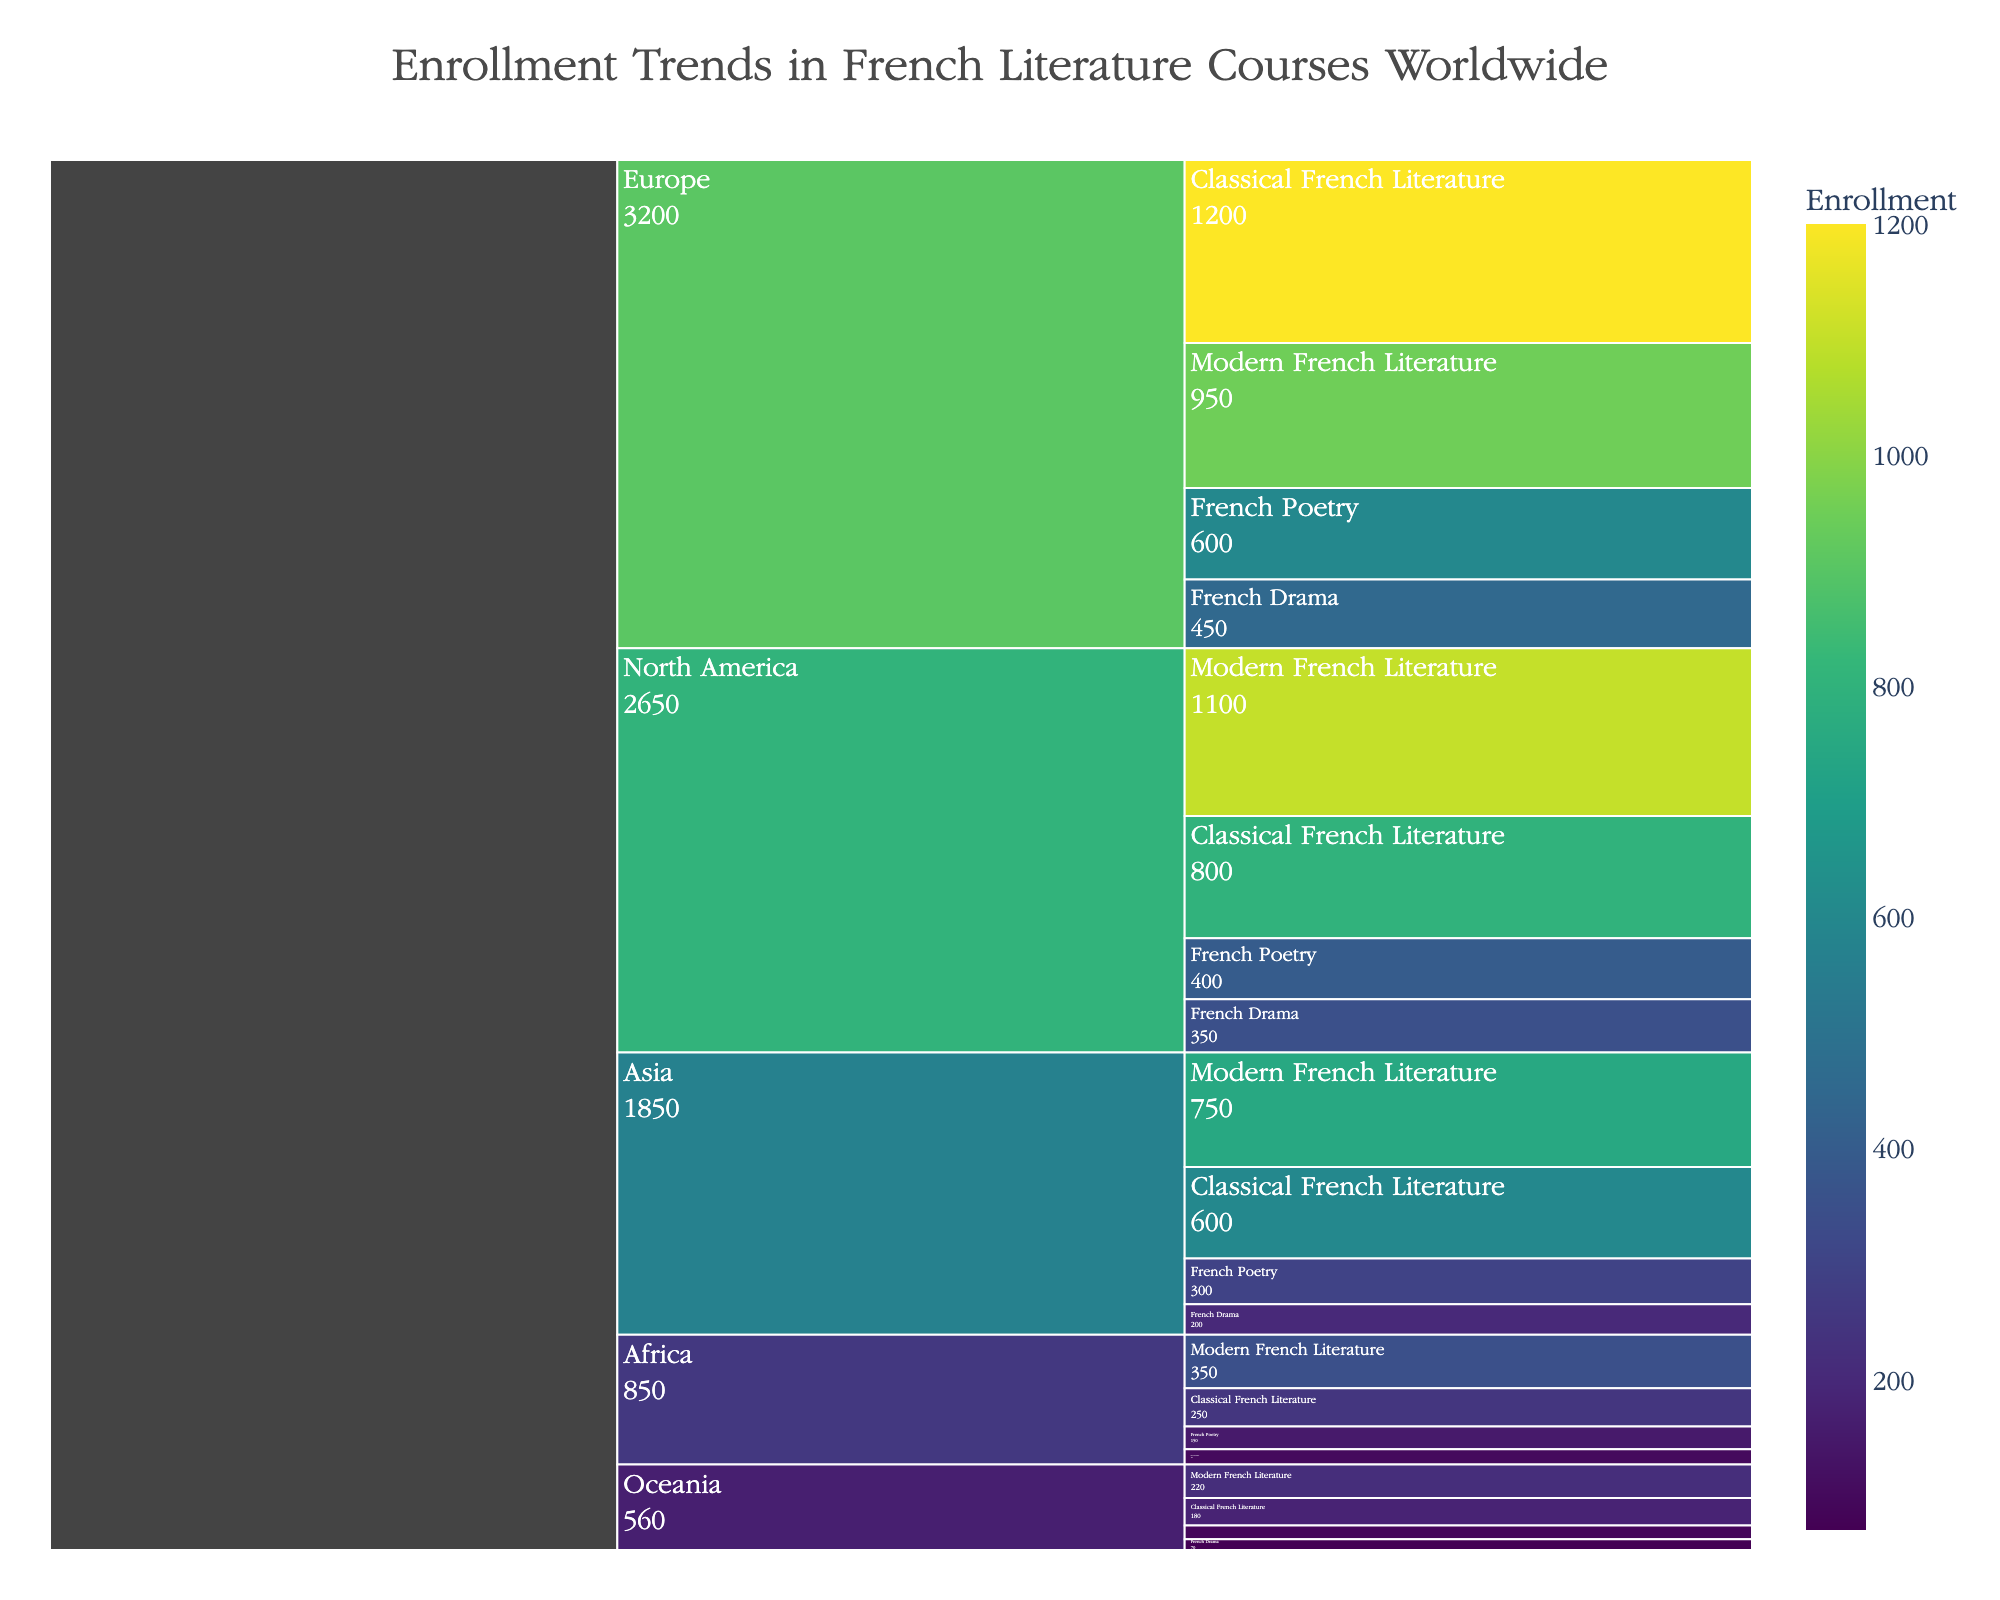What is the title of the icicle chart? The title of the icicle chart is prominently displayed at the top, helping viewers understand the chart's focus.
Answer: Enrollment Trends in French Literature Courses Worldwide Which region has the highest enrollment in Modern French Literature courses? To find this, look at the Modern French Literature section and identify the region with the largest enrollment value.
Answer: North America What is the total enrollment in all French Drama courses combined? Sum the enrollment numbers for French Drama courses across all regions: 450 (Europe) + 350 (North America) + 200 (Asia) + 100 (Africa) + 70 (Oceania).
Answer: 1170 How does enrollment in French Poetry in Europe compare to that in North America? Compare the specific enrollment values for French Poetry in Europe and North America directly. Europe has 600 while North America has 400.
Answer: Europe has higher enrollment by 200 Which region exhibits the lowest total enrollment across all French literature courses? Sum the enrollments from each region and identify the one with the smallest total. Oceania: 180 + 220 + 90 + 70 = 560, Africa: 250 + 350 + 150 + 100 = 850, Asia: 600 + 750 + 300 + 200 = 1850, North America: 800 + 1100 + 400 + 350 = 2650, Europe: 1200 + 950 + 600 + 450 = 3200.
Answer: Oceania What is the combined enrollment for Classical and Modern French Literature courses in Asia? Add the enrollment values for Classical French Literature (600) and Modern French Literature (750) in Asia.
Answer: 1350 Which course type has the highest enrollment in Europe? Look at the enrollment values for each course type in Europe and select the highest one.
Answer: Classical French Literature Compare the total enrollment in French Literature courses between Europe and North America. Sum the enrollments in all French literature courses for both Europe and North America, then compare. Europe: 1200 + 950 + 600 + 450 = 3200, North America: 800 + 1100 + 400 + 350 = 2650. Europe has higher enrollment by 550.
Answer: Europe has higher enrollment by 550 What proportion of the total enrollment in Europe is attributed to French Poetry? Calculate the total enrollment in Europe (3200) and then find the proportion from French Poetry (600): 600/3200.
Answer: 18.75% From a regional perspective, which literature course shows the most uniform distribution in enrollments across the regions? Compare the range (maximum-minimum) of enrollments for each course type across all regions. For example, check Classical French Literature, Modern French Literature, etc., to see if their enrollments are close in value.
Answer: Classical French Literature 